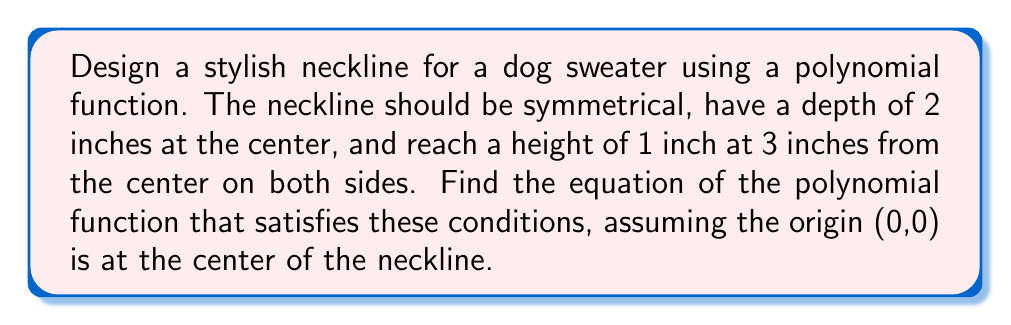Show me your answer to this math problem. Let's approach this step-by-step:

1) We need a polynomial function that is symmetrical about the y-axis, so it should only have even powers of x. Let's use a 4th degree polynomial:

   $$f(x) = ax^4 + bx^2 + c$$

2) We have three conditions to satisfy:
   a) f(0) = -2 (depth of 2 inches at the center)
   b) f(3) = 1 (height of 1 inch at 3 inches from the center)
   c) f'(3) = 0 (the slope should be zero at the highest point)

3) From condition (a):
   $$f(0) = c = -2$$

4) From condition (b):
   $$f(3) = 81a + 9b - 2 = 1$$
   $$81a + 9b = 3$$ (Equation 1)

5) To apply condition (c), we need to find f'(x):
   $$f'(x) = 4ax^3 + 2bx$$

   Then:
   $$f'(3) = 108a + 6b = 0$$ (Equation 2)

6) Now we have two equations with two unknowns:
   Equation 1: 81a + 9b = 3
   Equation 2: 108a + 6b = 0

7) Multiply Equation 2 by 3/2:
   162a + 9b = 0

8) Subtract this from Equation 1:
   -81a = 3
   a = -1/27

9) Substitute this back into Equation 2:
   108(-1/27) + 6b = 0
   -4 + 6b = 0
   b = 2/3

10) Therefore, our polynomial function is:
    $$f(x) = -\frac{1}{27}x^4 + \frac{2}{3}x^2 - 2$$
Answer: $$f(x) = -\frac{1}{27}x^4 + \frac{2}{3}x^2 - 2$$ 